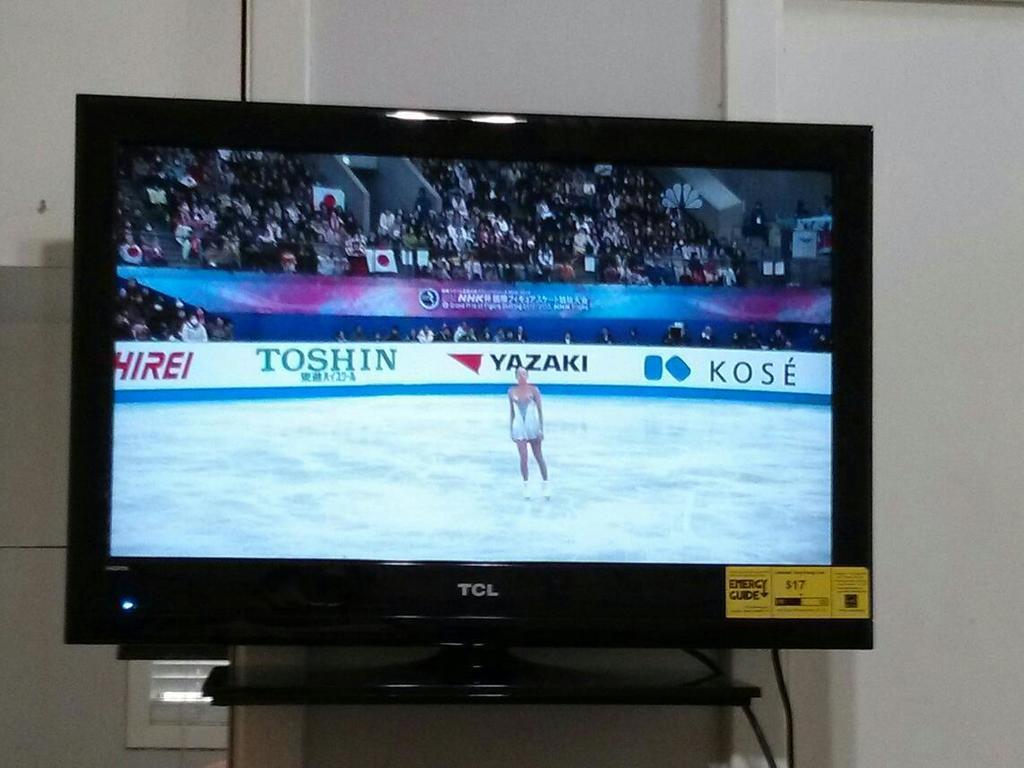Who are one of the sponsors of the ice skating event?
Offer a very short reply. Toshin. 